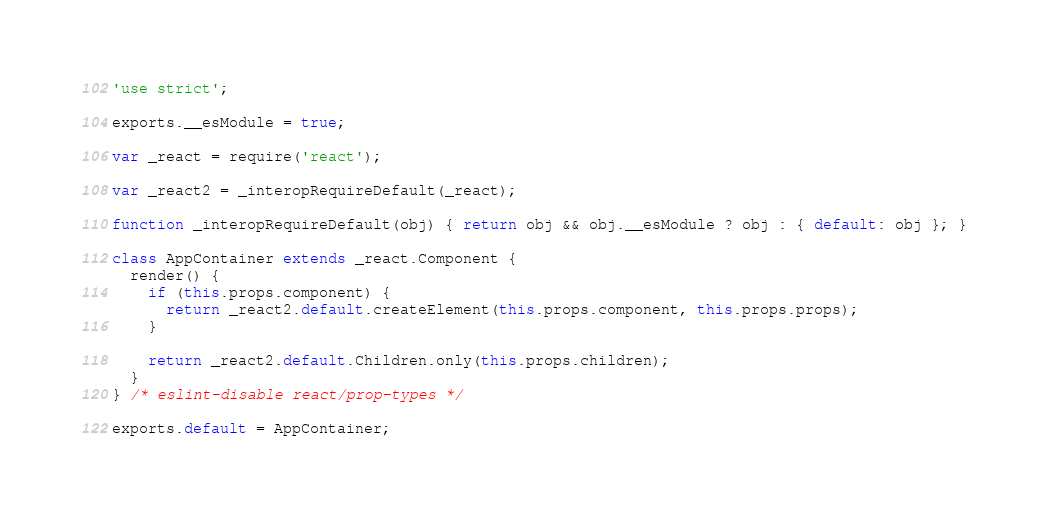Convert code to text. <code><loc_0><loc_0><loc_500><loc_500><_JavaScript_>'use strict';

exports.__esModule = true;

var _react = require('react');

var _react2 = _interopRequireDefault(_react);

function _interopRequireDefault(obj) { return obj && obj.__esModule ? obj : { default: obj }; }

class AppContainer extends _react.Component {
  render() {
    if (this.props.component) {
      return _react2.default.createElement(this.props.component, this.props.props);
    }

    return _react2.default.Children.only(this.props.children);
  }
} /* eslint-disable react/prop-types */

exports.default = AppContainer;</code> 